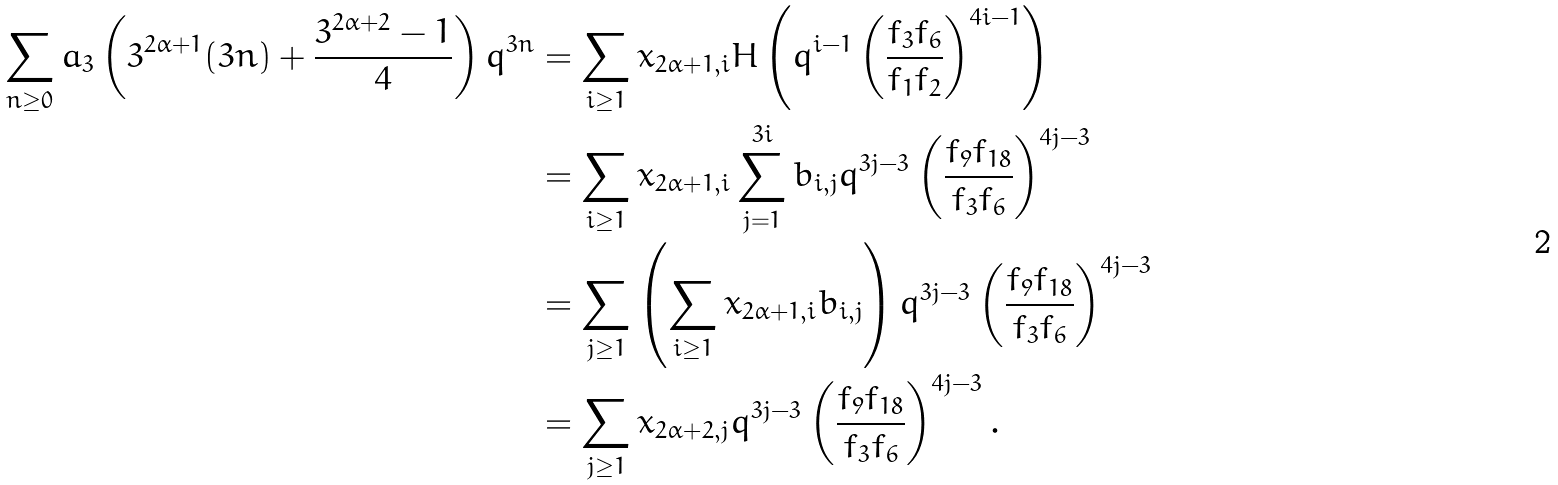Convert formula to latex. <formula><loc_0><loc_0><loc_500><loc_500>\sum _ { n \geq 0 } a _ { 3 } \left ( 3 ^ { 2 \alpha + 1 } ( 3 n ) + \frac { 3 ^ { 2 \alpha + 2 } - 1 } { 4 } \right ) q ^ { 3 n } & = \sum _ { i \geq 1 } x _ { 2 \alpha + 1 , i } H \left ( q ^ { i - 1 } \left ( \frac { f _ { 3 } f _ { 6 } } { f _ { 1 } f _ { 2 } } \right ) ^ { 4 i - 1 } \right ) \\ & = \sum _ { i \geq 1 } x _ { 2 \alpha + 1 , i } \sum _ { j = 1 } ^ { 3 i } b _ { i , j } q ^ { 3 j - 3 } \left ( \frac { f _ { 9 } f _ { 1 8 } } { f _ { 3 } f _ { 6 } } \right ) ^ { 4 j - 3 } \\ & = \sum _ { j \geq 1 } \left ( \sum _ { i \geq 1 } x _ { 2 \alpha + 1 , i } b _ { i , j } \right ) q ^ { 3 j - 3 } \left ( \frac { f _ { 9 } f _ { 1 8 } } { f _ { 3 } f _ { 6 } } \right ) ^ { 4 j - 3 } \\ & = \sum _ { j \geq 1 } x _ { 2 \alpha + 2 , j } q ^ { 3 j - 3 } \left ( \frac { f _ { 9 } f _ { 1 8 } } { f _ { 3 } f _ { 6 } } \right ) ^ { 4 j - 3 } .</formula> 